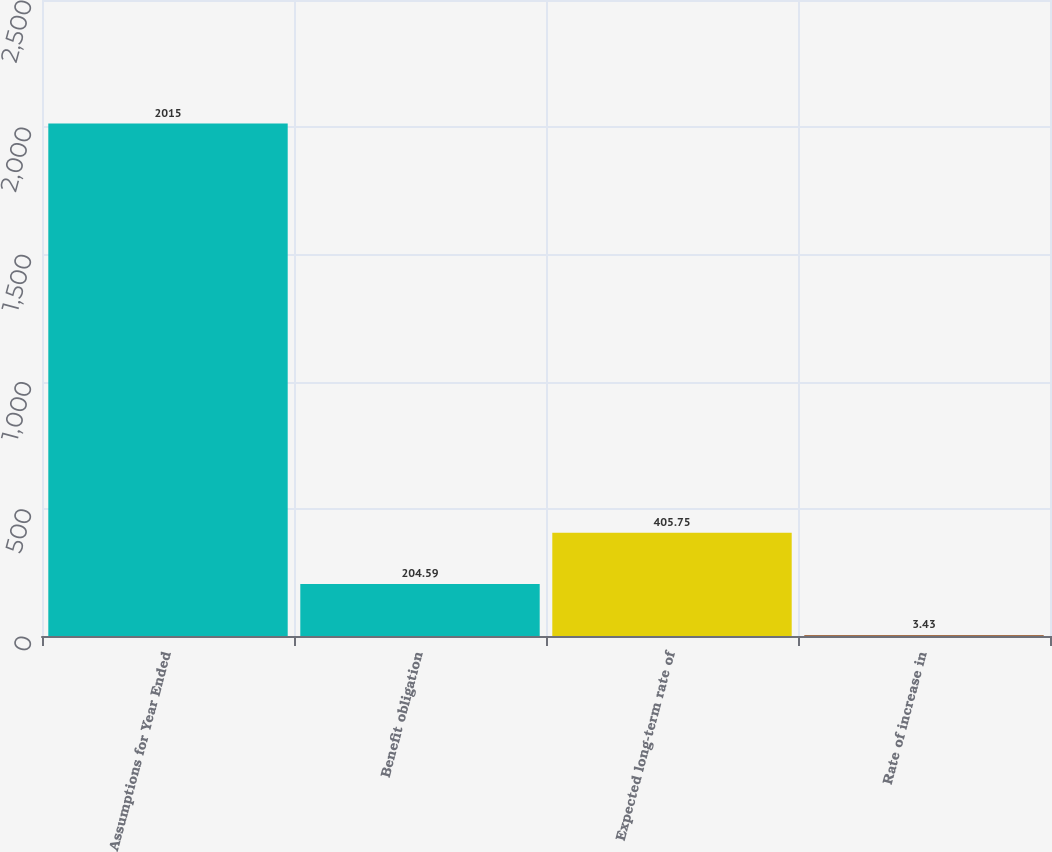Convert chart to OTSL. <chart><loc_0><loc_0><loc_500><loc_500><bar_chart><fcel>Assumptions for Year Ended<fcel>Benefit obligation<fcel>Expected long-term rate of<fcel>Rate of increase in<nl><fcel>2015<fcel>204.59<fcel>405.75<fcel>3.43<nl></chart> 